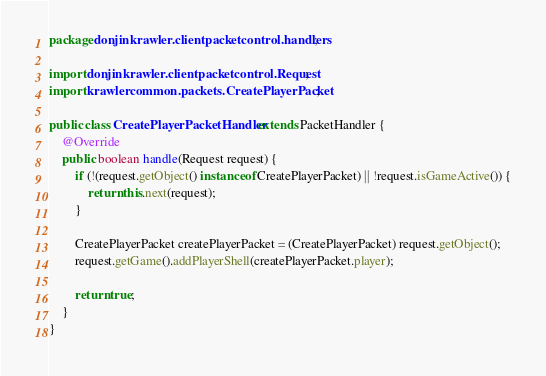<code> <loc_0><loc_0><loc_500><loc_500><_Java_>package donjinkrawler.clientpacketcontrol.handlers;

import donjinkrawler.clientpacketcontrol.Request;
import krawlercommon.packets.CreatePlayerPacket;

public class CreatePlayerPacketHandler extends PacketHandler {
    @Override
    public boolean handle(Request request) {
        if (!(request.getObject() instanceof CreatePlayerPacket) || !request.isGameActive()) {
            return this.next(request);
        }

        CreatePlayerPacket createPlayerPacket = (CreatePlayerPacket) request.getObject();
        request.getGame().addPlayerShell(createPlayerPacket.player);

        return true;
    }
}
</code> 